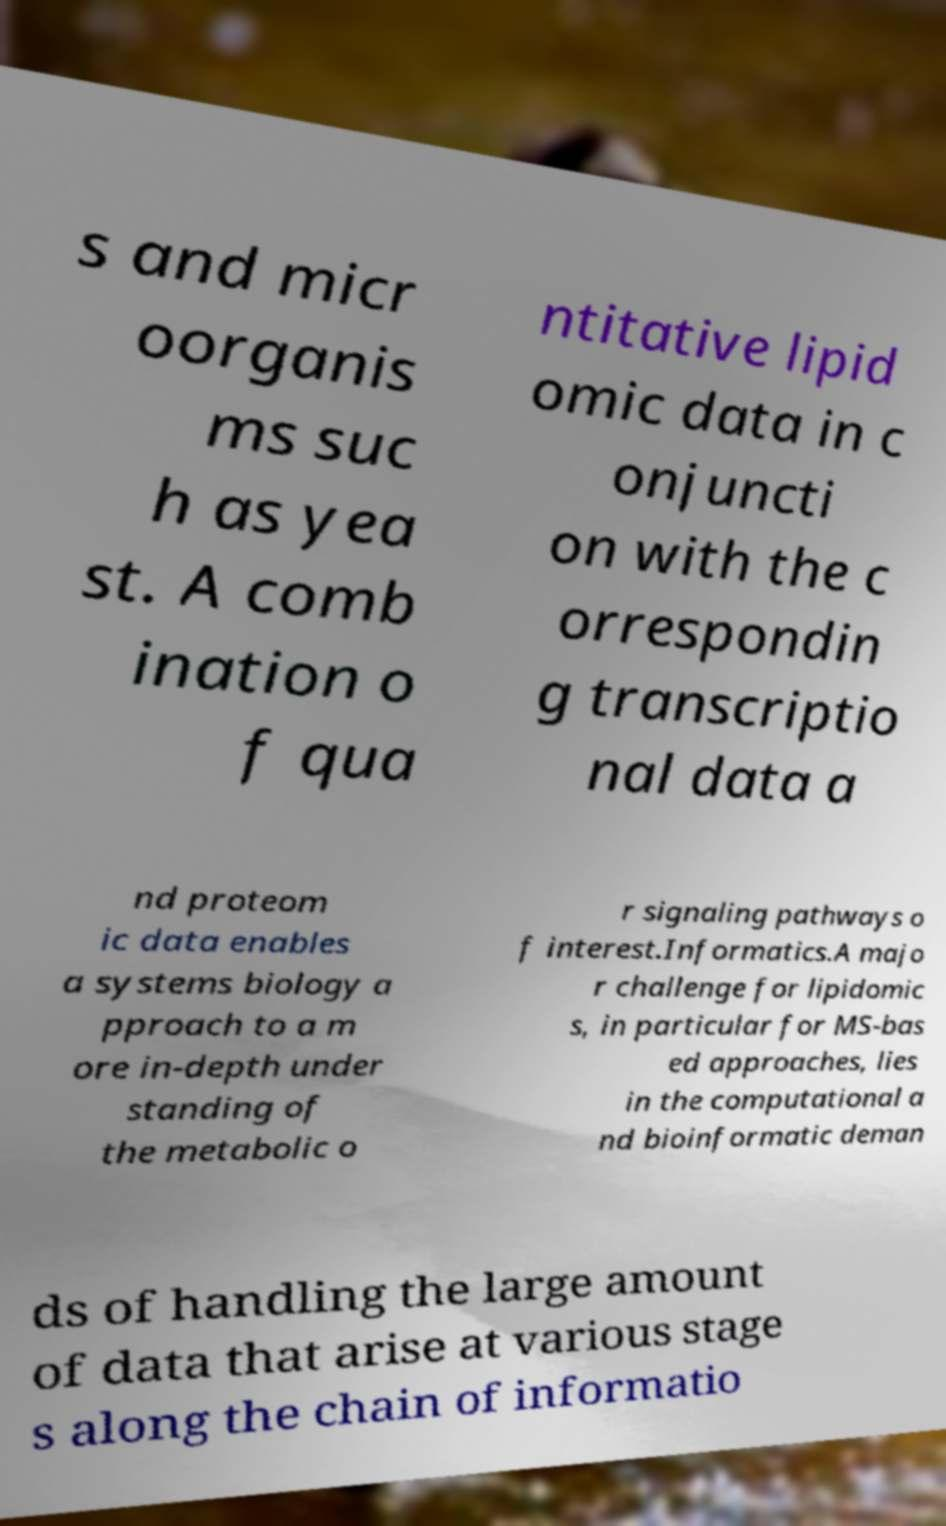Please identify and transcribe the text found in this image. s and micr oorganis ms suc h as yea st. A comb ination o f qua ntitative lipid omic data in c onjuncti on with the c orrespondin g transcriptio nal data a nd proteom ic data enables a systems biology a pproach to a m ore in-depth under standing of the metabolic o r signaling pathways o f interest.Informatics.A majo r challenge for lipidomic s, in particular for MS-bas ed approaches, lies in the computational a nd bioinformatic deman ds of handling the large amount of data that arise at various stage s along the chain of informatio 